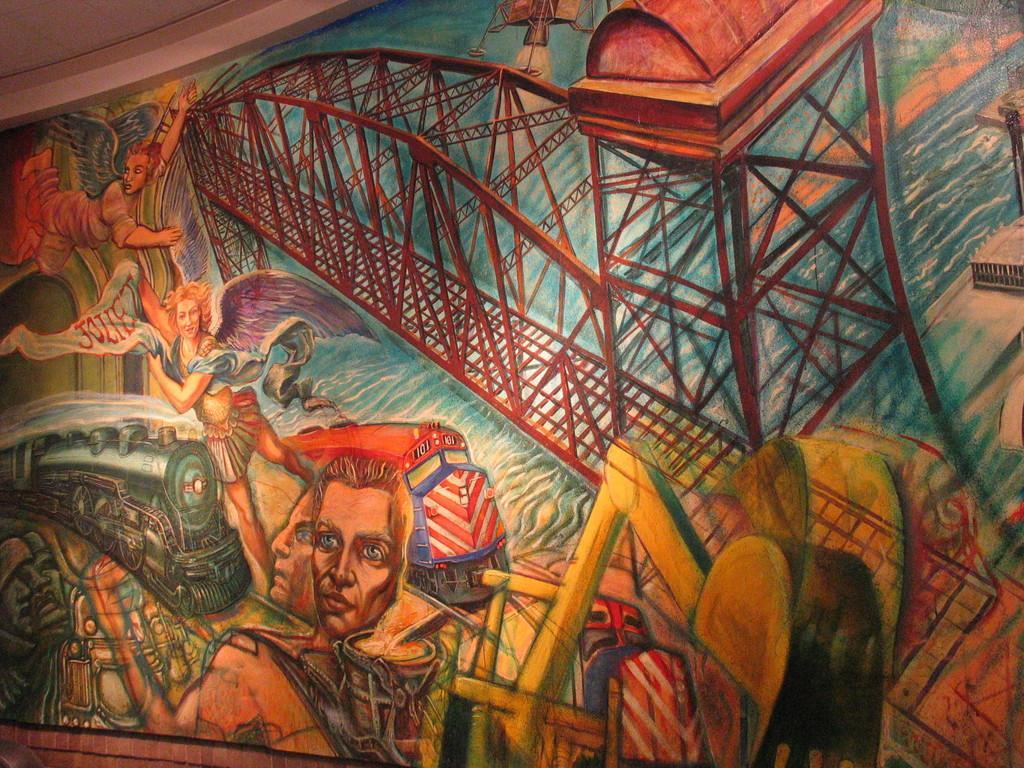Could you give a brief overview of what you see in this image? In this image I can see a huge painting in which I can see few persons, a train, a bridge and the water. To the top of the image I can see the ceiling. 